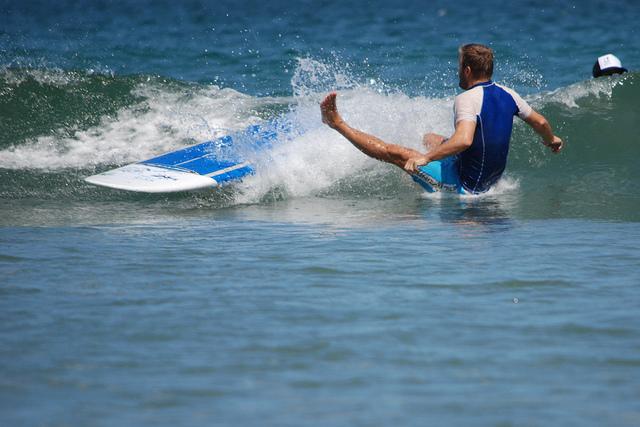Is this person an experienced surfer?
Give a very brief answer. No. What color is the water?
Be succinct. Blue. Is he falling?
Short answer required. Yes. What has happened to the man?
Keep it brief. Fell off. What was the man doing before he fell?
Write a very short answer. Surfing. Is the surfer falling off the surfboard?
Be succinct. Yes. 